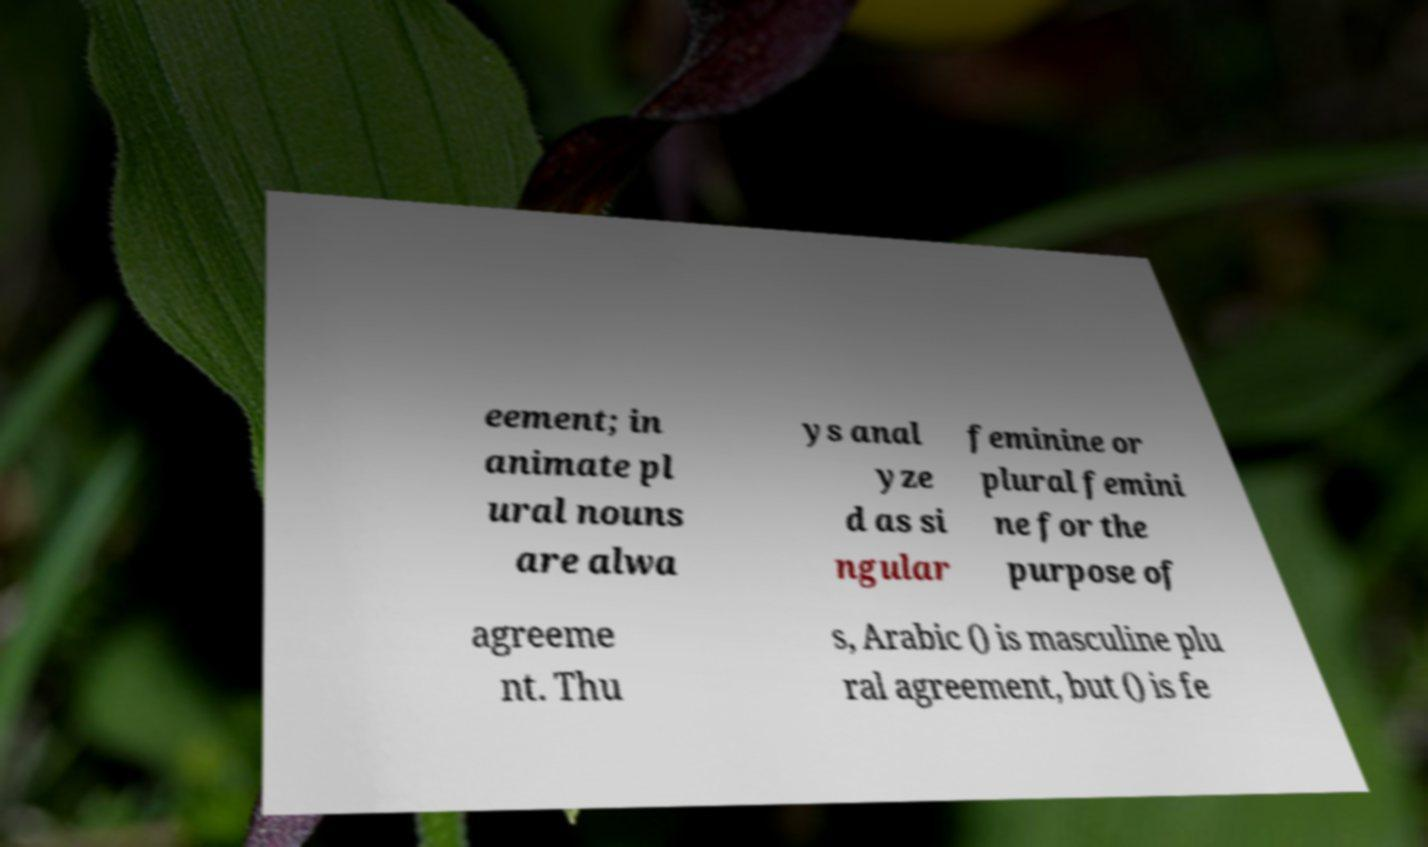I need the written content from this picture converted into text. Can you do that? eement; in animate pl ural nouns are alwa ys anal yze d as si ngular feminine or plural femini ne for the purpose of agreeme nt. Thu s, Arabic () is masculine plu ral agreement, but () is fe 